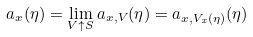<formula> <loc_0><loc_0><loc_500><loc_500>a _ { x } ( \eta ) = \lim _ { V \uparrow S } a _ { x , V } ( \eta ) = a _ { x , V _ { x } ( \eta ) } ( \eta )</formula> 